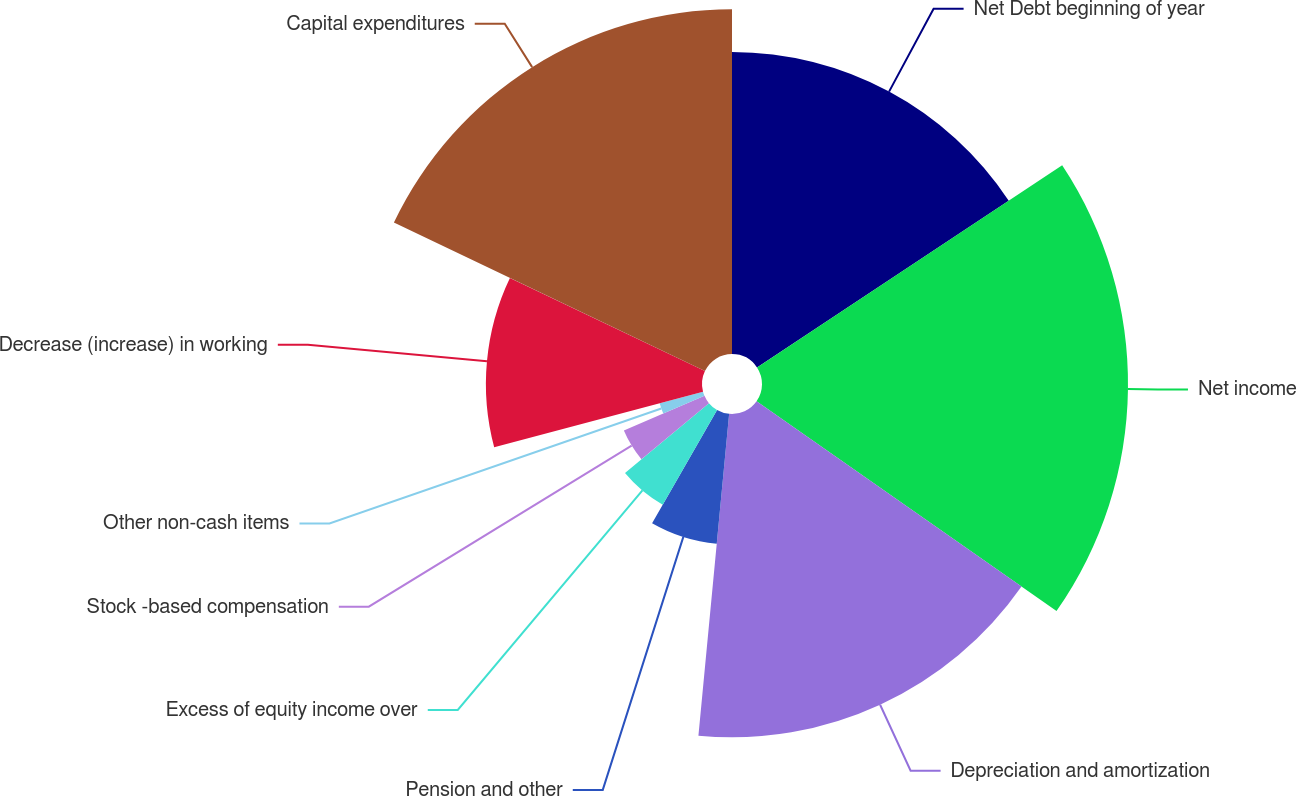Convert chart. <chart><loc_0><loc_0><loc_500><loc_500><pie_chart><fcel>Net Debt beginning of year<fcel>Net income<fcel>Depreciation and amortization<fcel>Pension and other<fcel>Excess of equity income over<fcel>Stock -based compensation<fcel>Other non-cash items<fcel>Decrease (increase) in working<fcel>Capital expenditures<nl><fcel>15.69%<fcel>19.02%<fcel>16.8%<fcel>6.78%<fcel>5.67%<fcel>4.56%<fcel>2.33%<fcel>11.23%<fcel>17.91%<nl></chart> 